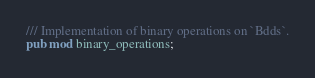<code> <loc_0><loc_0><loc_500><loc_500><_Rust_>/// Implementation of binary operations on `Bdds`.
pub mod binary_operations;
</code> 